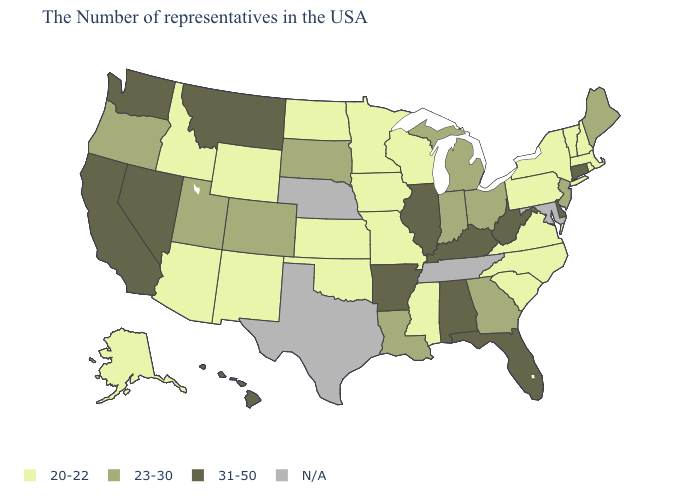What is the lowest value in states that border Indiana?
Keep it brief. 23-30. What is the lowest value in the USA?
Be succinct. 20-22. Name the states that have a value in the range 23-30?
Short answer required. Maine, New Jersey, Ohio, Georgia, Michigan, Indiana, Louisiana, South Dakota, Colorado, Utah, Oregon. What is the value of Kansas?
Be succinct. 20-22. Is the legend a continuous bar?
Write a very short answer. No. What is the value of Texas?
Concise answer only. N/A. Among the states that border Tennessee , which have the lowest value?
Keep it brief. Virginia, North Carolina, Mississippi, Missouri. Which states have the highest value in the USA?
Quick response, please. Connecticut, Delaware, West Virginia, Florida, Kentucky, Alabama, Illinois, Arkansas, Montana, Nevada, California, Washington, Hawaii. Name the states that have a value in the range 23-30?
Give a very brief answer. Maine, New Jersey, Ohio, Georgia, Michigan, Indiana, Louisiana, South Dakota, Colorado, Utah, Oregon. Which states have the lowest value in the USA?
Quick response, please. Massachusetts, Rhode Island, New Hampshire, Vermont, New York, Pennsylvania, Virginia, North Carolina, South Carolina, Wisconsin, Mississippi, Missouri, Minnesota, Iowa, Kansas, Oklahoma, North Dakota, Wyoming, New Mexico, Arizona, Idaho, Alaska. Among the states that border North Dakota , does Montana have the highest value?
Quick response, please. Yes. Name the states that have a value in the range N/A?
Concise answer only. Maryland, Tennessee, Nebraska, Texas. What is the value of Nebraska?
Short answer required. N/A. Name the states that have a value in the range N/A?
Be succinct. Maryland, Tennessee, Nebraska, Texas. 